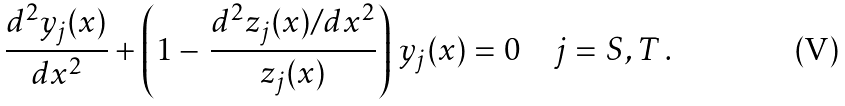<formula> <loc_0><loc_0><loc_500><loc_500>\frac { d ^ { 2 } y _ { j } ( x ) } { d x ^ { 2 } } + \left ( 1 - \, \frac { d ^ { 2 } z _ { j } ( x ) / d x ^ { 2 } } { z _ { j } ( x ) } \right ) \, y _ { j } ( x ) = 0 \quad j = S , T \, .</formula> 